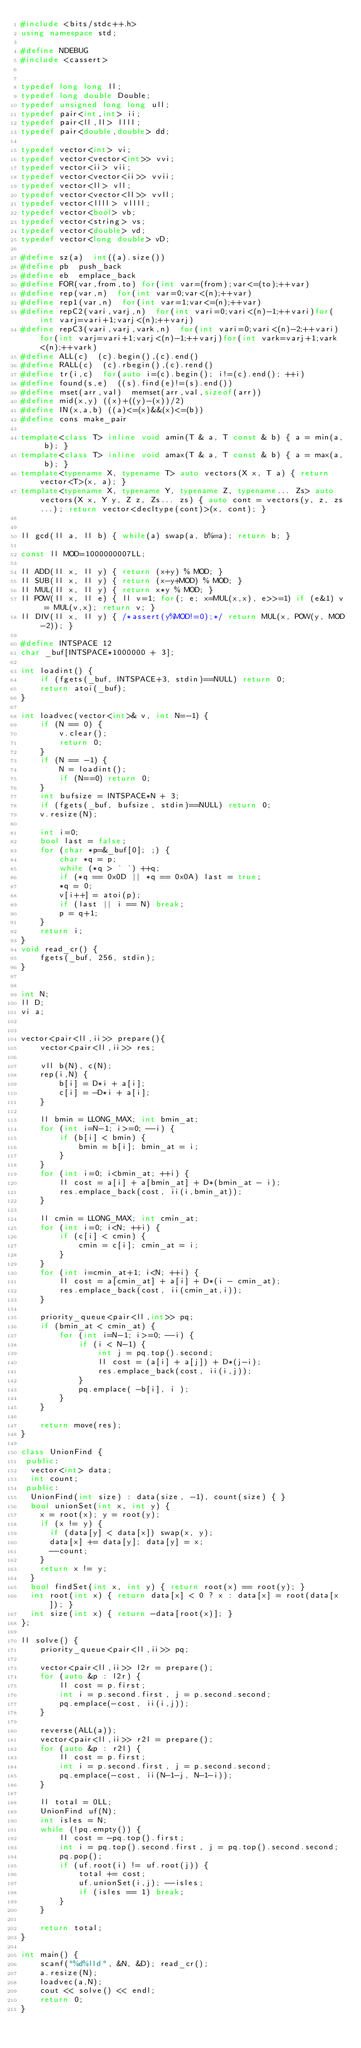<code> <loc_0><loc_0><loc_500><loc_500><_C++_>#include <bits/stdc++.h>
using namespace std;

#define NDEBUG
#include <cassert>


typedef long long ll;
typedef long double Double;
typedef unsigned long long ull;
typedef pair<int,int> ii;
typedef pair<ll,ll> llll;
typedef pair<double,double> dd;

typedef vector<int> vi;
typedef vector<vector<int>> vvi;
typedef vector<ii> vii;
typedef vector<vector<ii>> vvii;
typedef vector<ll> vll;
typedef vector<vector<ll>> vvll;
typedef vector<llll> vllll;
typedef vector<bool> vb;
typedef vector<string> vs;
typedef vector<double> vd;
typedef vector<long double> vD;

#define sz(a)  int((a).size())
#define pb  push_back
#define eb  emplace_back
#define FOR(var,from,to) for(int var=(from);var<=(to);++var)
#define rep(var,n)  for(int var=0;var<(n);++var)
#define rep1(var,n)  for(int var=1;var<=(n);++var)
#define repC2(vari,varj,n)  for(int vari=0;vari<(n)-1;++vari)for(int varj=vari+1;varj<(n);++varj)
#define repC3(vari,varj,vark,n)  for(int vari=0;vari<(n)-2;++vari)for(int varj=vari+1;varj<(n)-1;++varj)for(int vark=varj+1;vark<(n);++vark)
#define ALL(c)  (c).begin(),(c).end()
#define RALL(c)  (c).rbegin(),(c).rend()
#define tr(i,c)  for(auto i=(c).begin(); i!=(c).end(); ++i)
#define found(s,e)  ((s).find(e)!=(s).end())
#define mset(arr,val)  memset(arr,val,sizeof(arr))
#define mid(x,y) ((x)+((y)-(x))/2)
#define IN(x,a,b) ((a)<=(x)&&(x)<=(b))
#define cons make_pair

template<class T> inline void amin(T & a, T const & b) { a = min(a, b); }
template<class T> inline void amax(T & a, T const & b) { a = max(a, b); }
template<typename X, typename T> auto vectors(X x, T a) { return vector<T>(x, a); }
template<typename X, typename Y, typename Z, typename... Zs> auto vectors(X x, Y y, Z z, Zs... zs) { auto cont = vectors(y, z, zs...); return vector<decltype(cont)>(x, cont); }


ll gcd(ll a, ll b) { while(a) swap(a, b%=a); return b; }

const ll MOD=1000000007LL;

ll ADD(ll x, ll y) { return (x+y) % MOD; }
ll SUB(ll x, ll y) { return (x-y+MOD) % MOD; }
ll MUL(ll x, ll y) { return x*y % MOD; }
ll POW(ll x, ll e) { ll v=1; for(; e; x=MUL(x,x), e>>=1) if (e&1) v = MUL(v,x); return v; }
ll DIV(ll x, ll y) { /*assert(y%MOD!=0);*/ return MUL(x, POW(y, MOD-2)); }

#define INTSPACE 12
char _buf[INTSPACE*1000000 + 3];

int loadint() {
    if (fgets(_buf, INTSPACE+3, stdin)==NULL) return 0;
    return atoi(_buf);
}

int loadvec(vector<int>& v, int N=-1) {
    if (N == 0) {
        v.clear();
        return 0;
    }
    if (N == -1) {
        N = loadint();
        if (N==0) return 0;
    }
    int bufsize = INTSPACE*N + 3;
    if (fgets(_buf, bufsize, stdin)==NULL) return 0;
    v.resize(N);

    int i=0;
    bool last = false;
    for (char *p=&_buf[0]; ;) {
        char *q = p;
        while (*q > ' ') ++q;
        if (*q == 0x0D || *q == 0x0A) last = true;
        *q = 0;
        v[i++] = atoi(p);
        if (last || i == N) break;
        p = q+1;
    }
    return i;
}
void read_cr() {
    fgets(_buf, 256, stdin);
}


int N;
ll D;
vi a;


vector<pair<ll,ii>> prepare(){
    vector<pair<ll,ii>> res;

    vll b(N), c(N);
    rep(i,N) {
        b[i] = D*i + a[i];
        c[i] = -D*i + a[i];
    }

    ll bmin = LLONG_MAX; int bmin_at;
    for (int i=N-1; i>=0; --i) {
        if (b[i] < bmin) {
            bmin = b[i]; bmin_at = i;
        }
    }
    for (int i=0; i<bmin_at; ++i) {
        ll cost = a[i] + a[bmin_at] + D*(bmin_at - i);
        res.emplace_back(cost, ii(i,bmin_at));
    }

    ll cmin = LLONG_MAX; int cmin_at;
    for (int i=0; i<N; ++i) {
        if (c[i] < cmin) {
            cmin = c[i]; cmin_at = i;
        }
    }
    for (int i=cmin_at+1; i<N; ++i) {
        ll cost = a[cmin_at] + a[i] + D*(i - cmin_at);
        res.emplace_back(cost, ii(cmin_at,i));
    }

    priority_queue<pair<ll,int>> pq;
    if (bmin_at < cmin_at) {
        for (int i=N-1; i>=0; --i) {
            if (i < N-1) {
                int j = pq.top().second;
                ll cost = (a[i] + a[j]) + D*(j-i);
                res.emplace_back(cost, ii(i,j));
            }
            pq.emplace( -b[i], i );
        }
    }

    return move(res);
}

class UnionFind {
 public:
  vector<int> data;
  int count;
 public:
  UnionFind(int size) : data(size, -1), count(size) { }
  bool unionSet(int x, int y) {
    x = root(x); y = root(y);
    if (x != y) {
      if (data[y] < data[x]) swap(x, y);
      data[x] += data[y]; data[y] = x;
      --count;
    }
    return x != y;
  }
  bool findSet(int x, int y) { return root(x) == root(y); }
  int root(int x) { return data[x] < 0 ? x : data[x] = root(data[x]); }
  int size(int x) { return -data[root(x)]; }
};

ll solve() {
    priority_queue<pair<ll,ii>> pq;

    vector<pair<ll,ii>> l2r = prepare();
    for (auto &p : l2r) {
        ll cost = p.first;
        int i = p.second.first, j = p.second.second;
        pq.emplace(-cost, ii(i,j));
    }

    reverse(ALL(a));
    vector<pair<ll,ii>> r2l = prepare();
    for (auto &p : r2l) {
        ll cost = p.first;
        int i = p.second.first, j = p.second.second;
        pq.emplace(-cost, ii(N-1-j, N-1-i));
    }

    ll total = 0LL;
    UnionFind uf(N);
    int isles = N;
    while (!pq.empty()) {
        ll cost = -pq.top().first;
        int i = pq.top().second.first, j = pq.top().second.second;
        pq.pop();
        if (uf.root(i) != uf.root(j)) {
            total += cost;
            uf.unionSet(i,j); --isles;
            if (isles == 1) break;
        }
    }

    return total;
}

int main() {
    scanf("%d%lld", &N, &D); read_cr();
    a.resize(N);
    loadvec(a,N);
    cout << solve() << endl;
    return 0;
}
</code> 